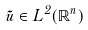Convert formula to latex. <formula><loc_0><loc_0><loc_500><loc_500>\tilde { u } \in L ^ { 2 } ( \mathbb { R } ^ { n } )</formula> 